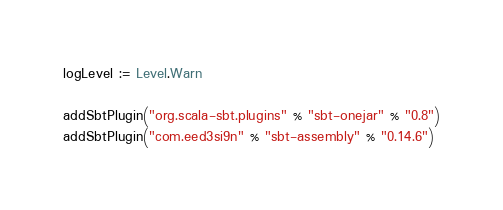Convert code to text. <code><loc_0><loc_0><loc_500><loc_500><_Scala_>logLevel := Level.Warn

addSbtPlugin("org.scala-sbt.plugins" % "sbt-onejar" % "0.8")
addSbtPlugin("com.eed3si9n" % "sbt-assembly" % "0.14.6")
</code> 